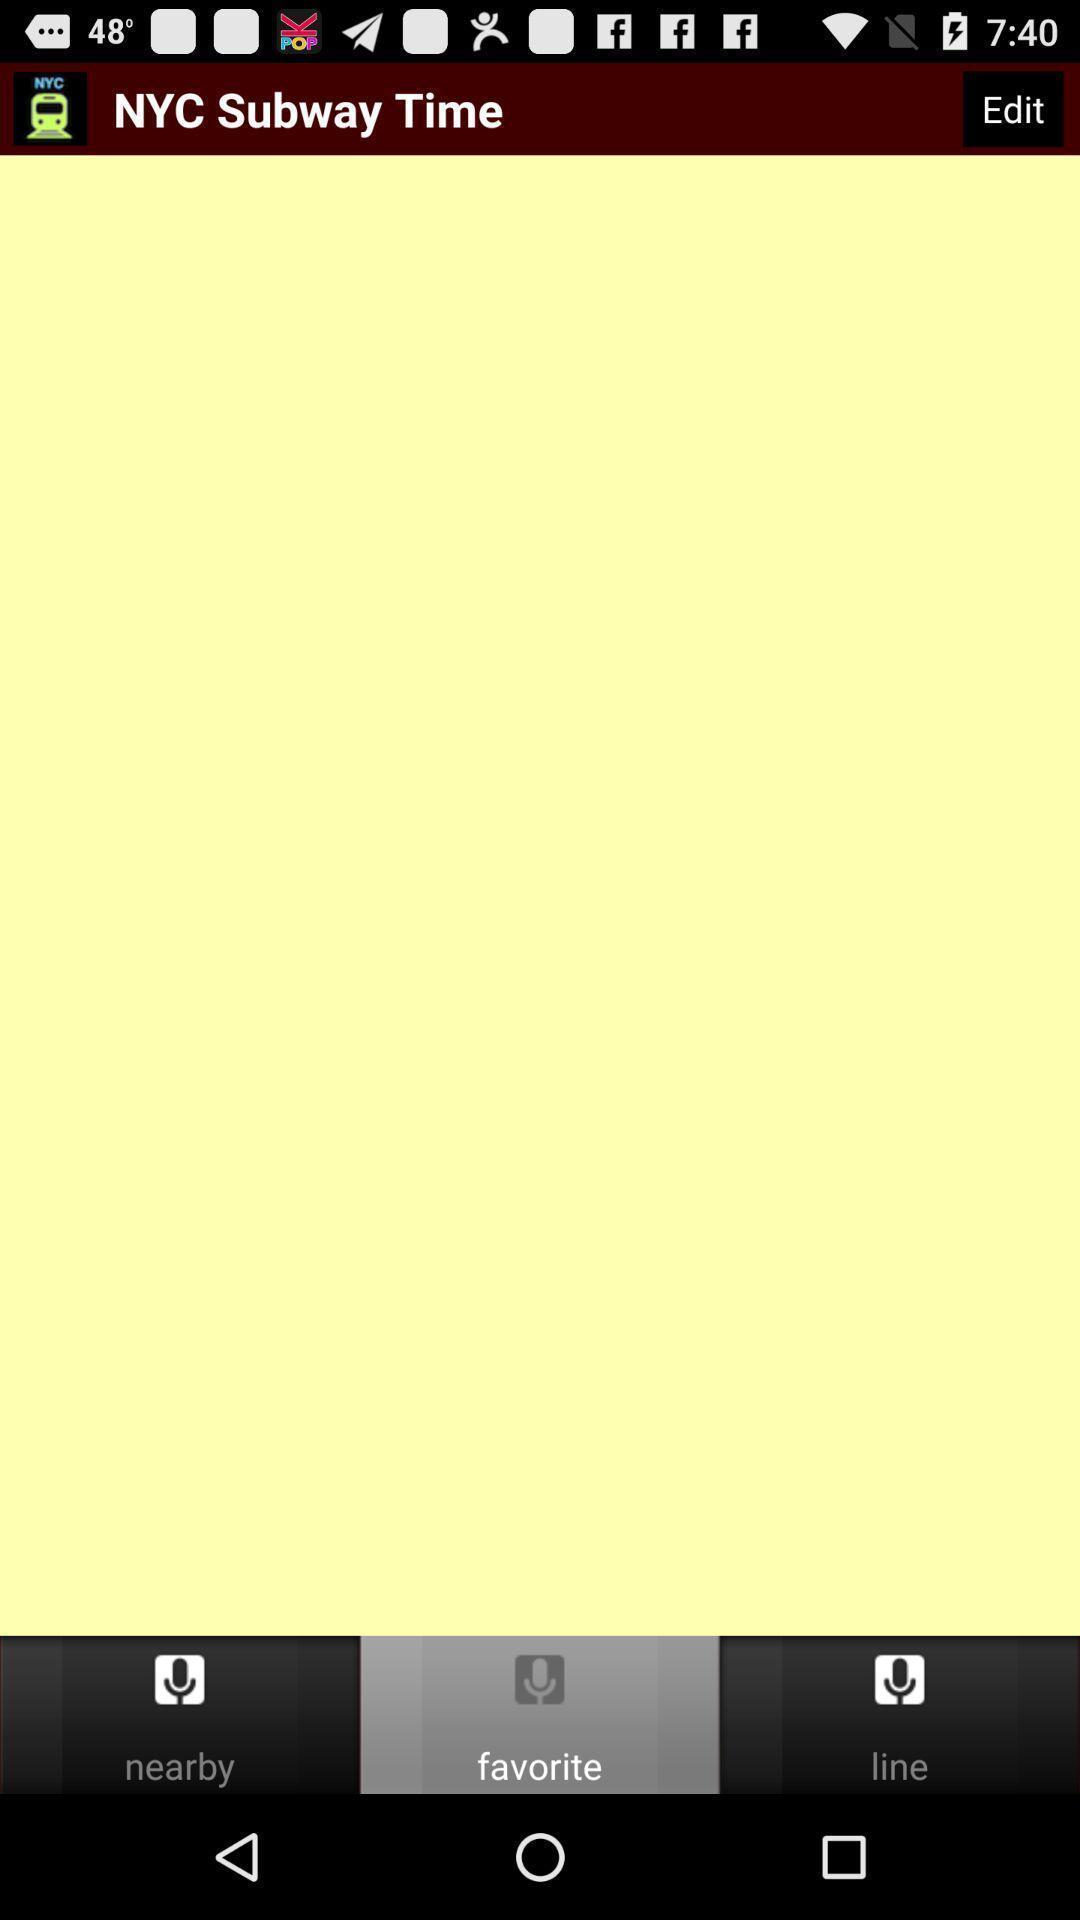Please provide a description for this image. Screen displaying various options on an app. 